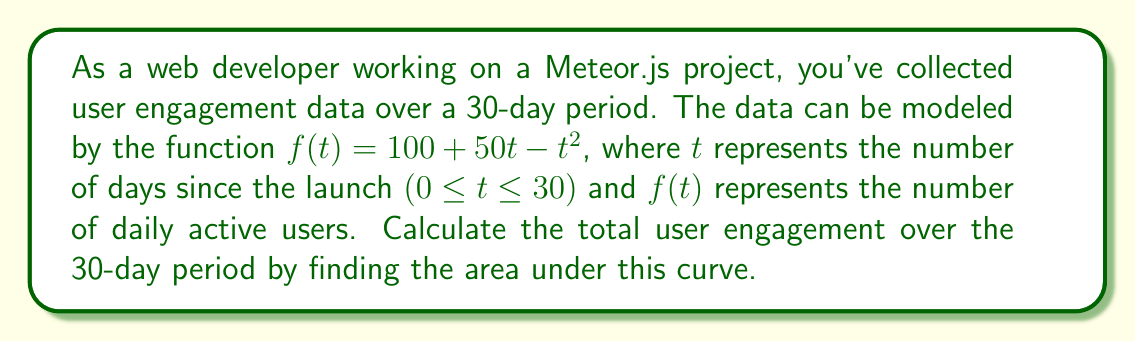What is the answer to this math problem? To calculate the area under the curve, we need to integrate the function $f(t)$ from 0 to 30. Here's how we do it step-by-step:

1. Set up the definite integral:
   $$\int_0^{30} (100 + 50t - t^2) dt$$

2. Integrate each term:
   $$\int_0^{30} 100 dt + \int_0^{30} 50t dt - \int_0^{30} t^2 dt$$

3. Solve each integral:
   $$[100t]_0^{30} + [25t^2]_0^{30} - [\frac{1}{3}t^3]_0^{30}$$

4. Evaluate the definite integral:
   $$(100 \cdot 30) + (25 \cdot 30^2) - (\frac{1}{3} \cdot 30^3) - (0 + 0 - 0)$$

5. Calculate the result:
   $$3000 + 22500 - 9000 = 16500$$

Therefore, the total user engagement over the 30-day period is 16,500 user-days.
Answer: 16,500 user-days 